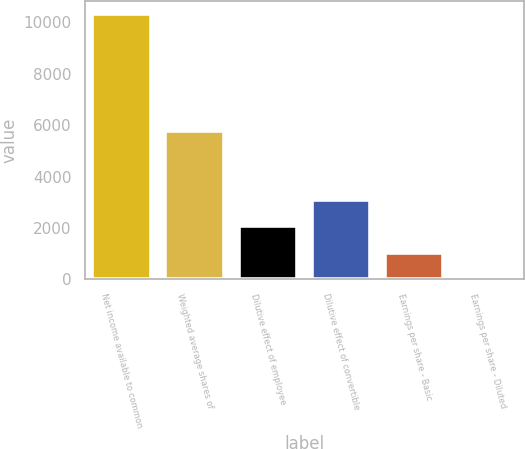Convert chart to OTSL. <chart><loc_0><loc_0><loc_500><loc_500><bar_chart><fcel>Net income available to common<fcel>Weighted average shares of<fcel>Dilutive effect of employee<fcel>Dilutive effect of convertible<fcel>Earnings per share - Basic<fcel>Earnings per share - Diluted<nl><fcel>10316<fcel>5761.39<fcel>2064.9<fcel>3096.29<fcel>1033.51<fcel>2.12<nl></chart> 